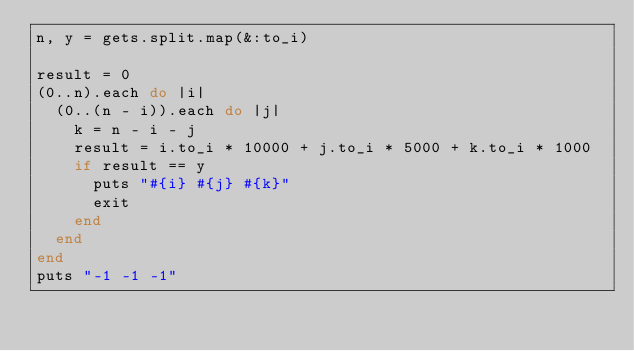Convert code to text. <code><loc_0><loc_0><loc_500><loc_500><_Ruby_>n, y = gets.split.map(&:to_i)

result = 0
(0..n).each do |i|
  (0..(n - i)).each do |j|
    k = n - i - j
    result = i.to_i * 10000 + j.to_i * 5000 + k.to_i * 1000
    if result == y
      puts "#{i} #{j} #{k}"
      exit
    end
  end
end
puts "-1 -1 -1"</code> 